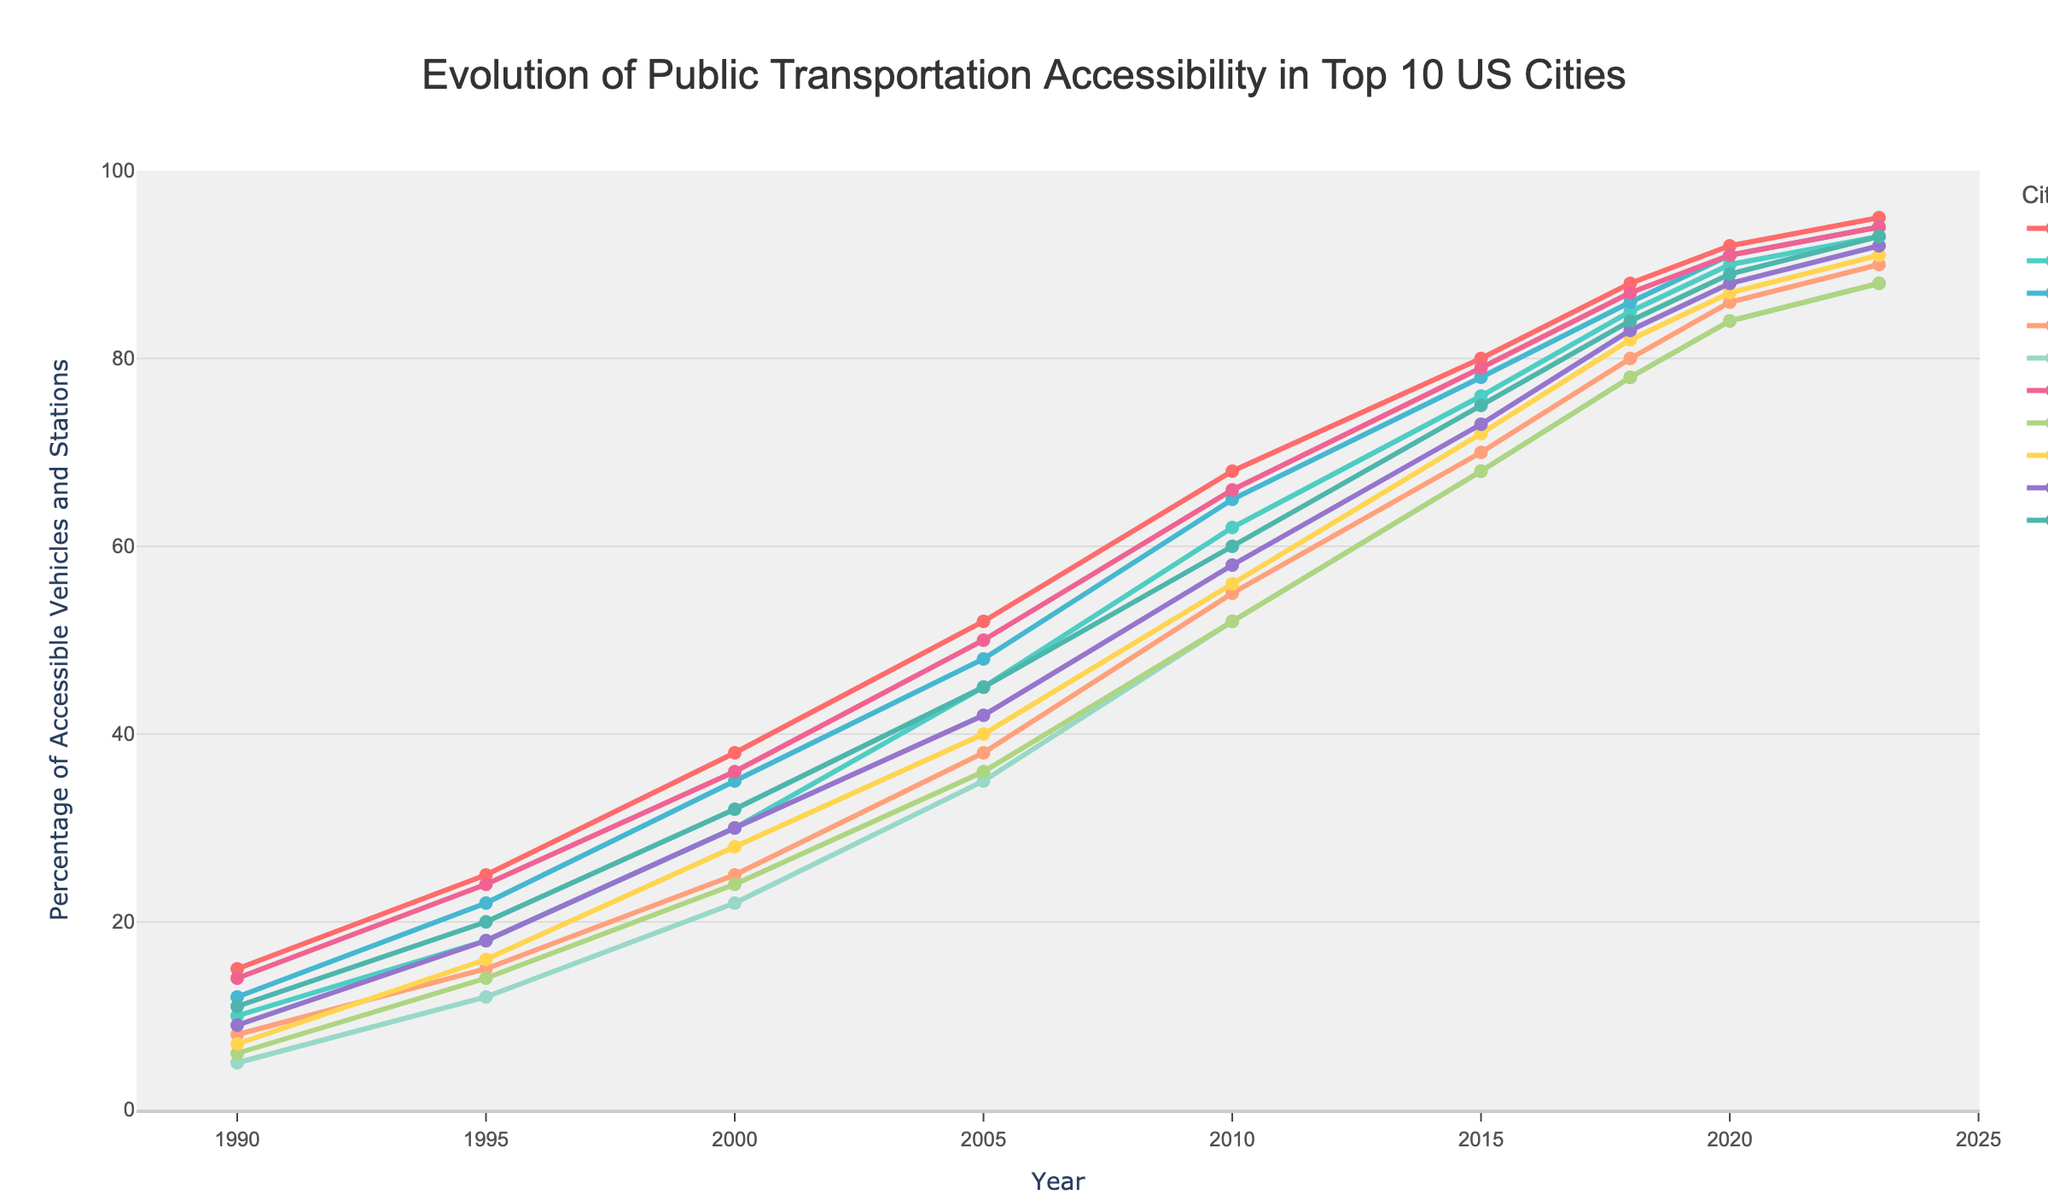Which city had the highest percentage of accessible vehicles and stations in 2023? According to the chart, New York had the highest percentage of accessible vehicles and stations in 2023, with a value of 95%.
Answer: New York How much did the accessibility percentage in Philadelphia increase from 1990 to 2023? In 1990, Philadelphia had 14% accessibility, and by 2023, it had increased to 94%. The increase is calculated as 94% - 14% = 80%.
Answer: 80% Which year saw the most significant percentage increase in accessibility for Los Angeles? From the chart, Los Angeles saw a significant percentage increase from 1990 (10%) to 1995 (18%), a jump of 8%. Another notable increase is from 1995 (18%) to 2000 (30%), an increase of 12%. The most significant increase is 12%.
Answer: 2000 In 2010, which cities had an accessibility percentage above 60%? According to the chart data, in 2010, New York (68%), Los Angeles (62%), Chicago (65%), and Philadelphia (66%) had an accessibility percentage above 60%.
Answer: New York, Los Angeles, Chicago, Philadelphia Which cities had the same percentage of accessibility in 2023? The chart shows that Los Angeles and San Diego both had 93% accessibility in 2023.
Answer: Los Angeles, San Diego What is the difference in accessibility percentage between Phoenix and San Antonio in 2020? In 2020, Phoenix had 84% accessibility, and San Antonio had 84% accessibility as well. The difference is 84% - 84% = 0%.
Answer: 0% Can you identify a period where San Antonio’s accessibility grew at a consistent rate? From 1990 to 2023, San Antonio's accessibility shows a considerable growth, particularly between 2005 (36%) and 2015 (68%), which translates to a steady increase around every 5 years.
Answer: 2005 to 2015 Which city experienced the least growth in accessibility from 1990 to 2023? Comparing the accessibility percentage from 1990 to 2023 for all cities, Phoenix had a starting point of 5% in 1990 and an ending point of 88% in 2023, showing the least growth compared to cities like New York or Chicago.
Answer: Phoenix Between 2000 and 2010, how did the growth rate in accessibility for Houston compare to Dallas? From 2000 to 2010, Houston grew from 25% to 55% (30% increase), while Dallas grew from 30% to 58% (28% increase). Houston had a slightly higher growth rate than Dallas.
Answer: Houston Is there a city that consistently had below-average accessibility throughout the years? By examining the chart, none of the cities consistently had below-average accessibility throughout the years. Most cities consistently improved their percentage of accessible vehicles and stations over the time period.
Answer: No 